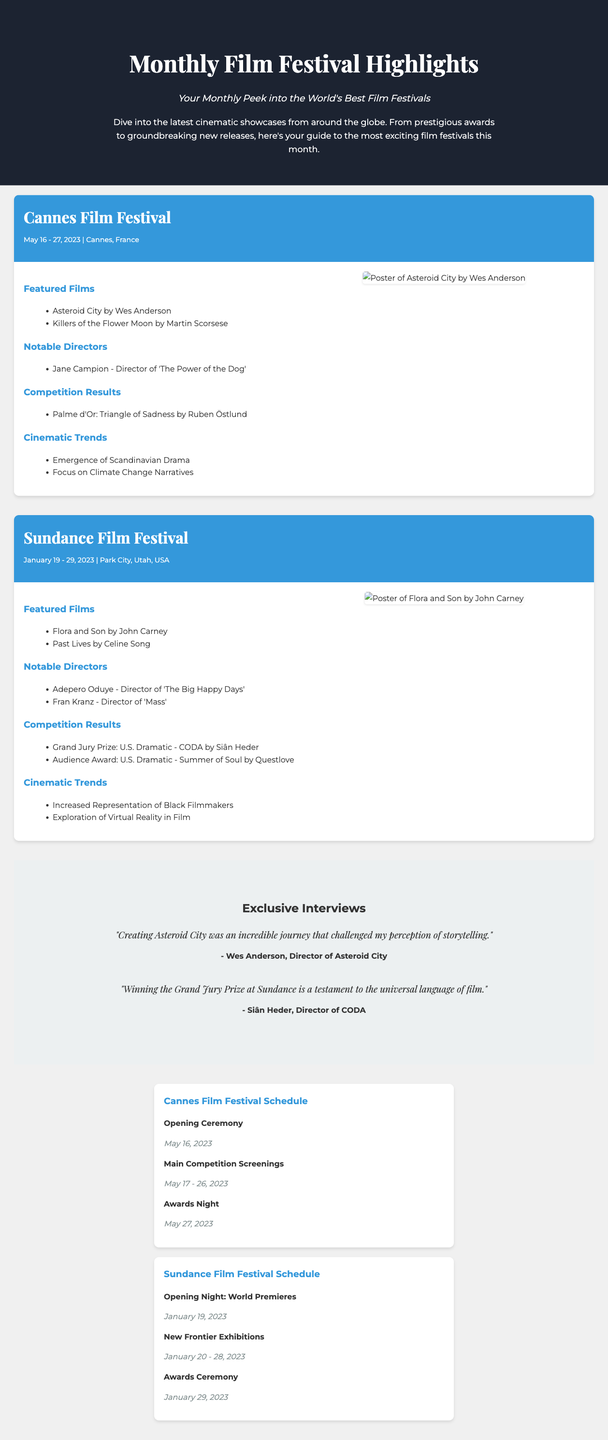What is the tagline of the document? The tagline provides a brief description of the document's focus, which is highlighted at the top.
Answer: Your Monthly Peek into the World's Best Film Festivals When was the Cannes Film Festival held? The date of the Cannes Film Festival is specified in the festival information section.
Answer: May 16 - 27, 2023 Who directed "Flora and Son"? The notable directors section lists key filmmakers along with their featured films.
Answer: John Carney What film won the Palme d'Or at the Cannes Film Festival? This information is outlined in the competition results under the Cannes Film Festival section.
Answer: Triangle of Sadness What notable trend is mentioned at the Cannes Film Festival? The cinematic trends section provides insights into current themes in the film industry.
Answer: Emergence of Scandinavian Drama How many films are listed under Featured Films for Sundance? The number of featured films is found by counting the items listed in the corresponding section.
Answer: 2 What is included in the schedules section of the document? The schedules section contains events related to the festivals, including dates and names.
Answer: Festival event schedules What quote is attributed to Wes Anderson? The exclusive interviews section provides quotes from directors, detailing their experiences.
Answer: "Creating Asteroid City was an incredible journey that challenged my perception of storytelling." 